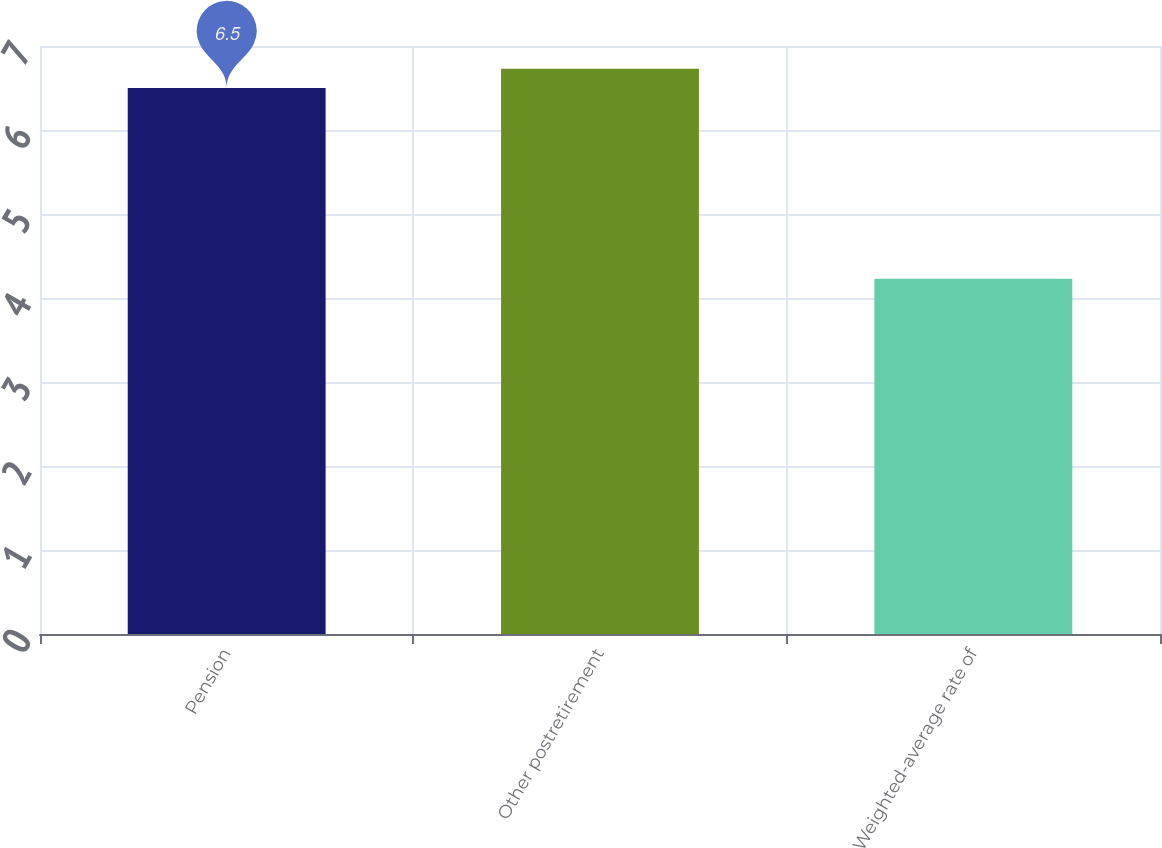<chart> <loc_0><loc_0><loc_500><loc_500><bar_chart><fcel>Pension<fcel>Other postretirement<fcel>Weighted-average rate of<nl><fcel>6.5<fcel>6.73<fcel>4.23<nl></chart> 